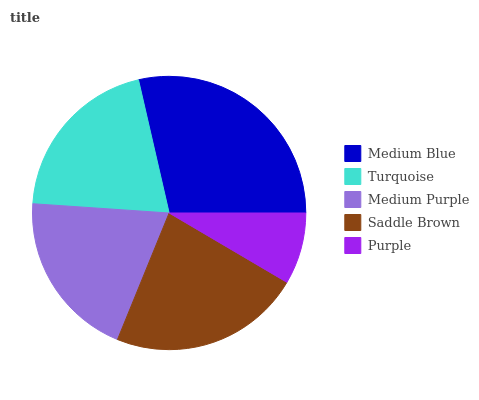Is Purple the minimum?
Answer yes or no. Yes. Is Medium Blue the maximum?
Answer yes or no. Yes. Is Turquoise the minimum?
Answer yes or no. No. Is Turquoise the maximum?
Answer yes or no. No. Is Medium Blue greater than Turquoise?
Answer yes or no. Yes. Is Turquoise less than Medium Blue?
Answer yes or no. Yes. Is Turquoise greater than Medium Blue?
Answer yes or no. No. Is Medium Blue less than Turquoise?
Answer yes or no. No. Is Turquoise the high median?
Answer yes or no. Yes. Is Turquoise the low median?
Answer yes or no. Yes. Is Medium Blue the high median?
Answer yes or no. No. Is Saddle Brown the low median?
Answer yes or no. No. 